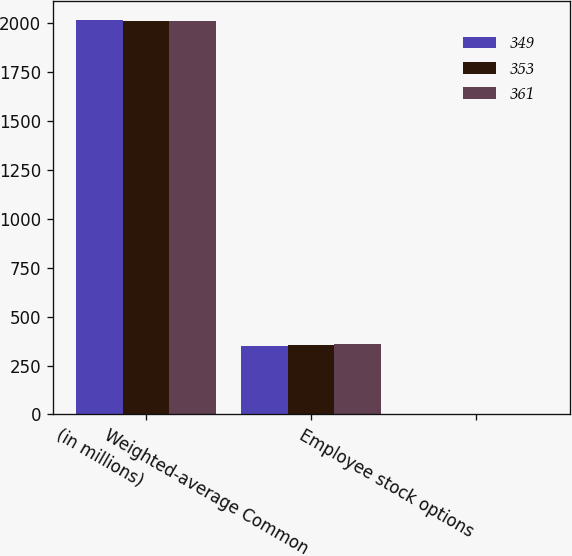<chart> <loc_0><loc_0><loc_500><loc_500><stacked_bar_chart><ecel><fcel>(in millions)<fcel>Weighted-average Common<fcel>Employee stock options<nl><fcel>349<fcel>2012<fcel>349<fcel>4<nl><fcel>353<fcel>2011<fcel>353<fcel>4<nl><fcel>361<fcel>2010<fcel>361<fcel>2<nl></chart> 